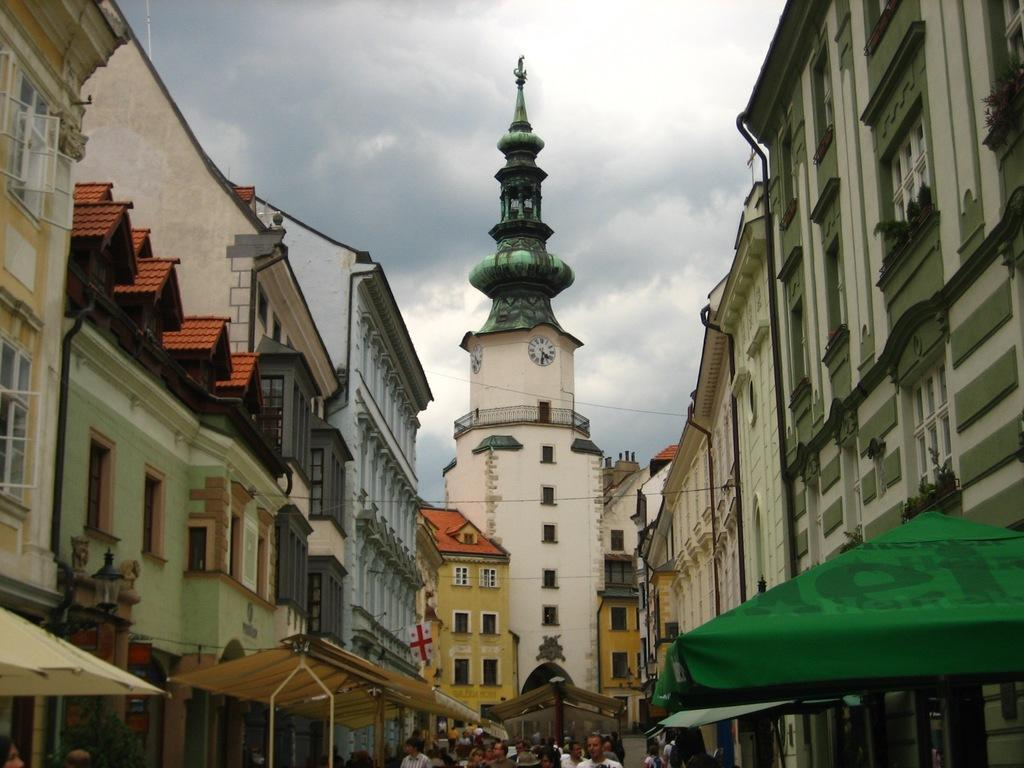Who or what can be seen at the bottom of the image? There are people at the bottom of the image. What type of structures are visible in the image? There are buildings visible in the image. What is located on the right side of the image? There is a tent on the right side of the image. What can be seen in the background of the image? The sky is visible in the background of the image. How many dogs are playing with the people at the bottom of the image? There are no dogs present in the image; it only shows people, buildings, a tent, and the sky. Are there any bears visible in the image? There are no bears present in the image. 